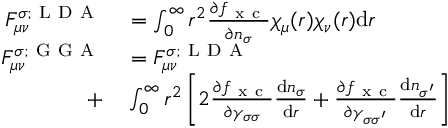<formula> <loc_0><loc_0><loc_500><loc_500>\begin{array} { r l } { F _ { \mu \nu } ^ { \sigma ; L D A } } & = \int _ { 0 } ^ { \infty } r ^ { 2 } \frac { \partial f _ { x c } } { \partial n _ { \sigma } } \chi _ { \mu } ( r ) \chi _ { \nu } ( r ) d r } \\ { F _ { \mu \nu } ^ { \sigma ; G G A } } & = F _ { \mu \nu } ^ { \sigma ; L D A } } \\ { + } & \int _ { 0 } ^ { \infty } r ^ { 2 } \left [ 2 \frac { \partial f _ { x c } } { \partial \gamma _ { \sigma \sigma } } \frac { d n _ { \sigma } } { d r } + \frac { \partial f _ { x c } } { \partial \gamma _ { \sigma \sigma ^ { \prime } } } \frac { d n _ { \sigma ^ { \prime } } } { d r } \right ] } \end{array}</formula> 